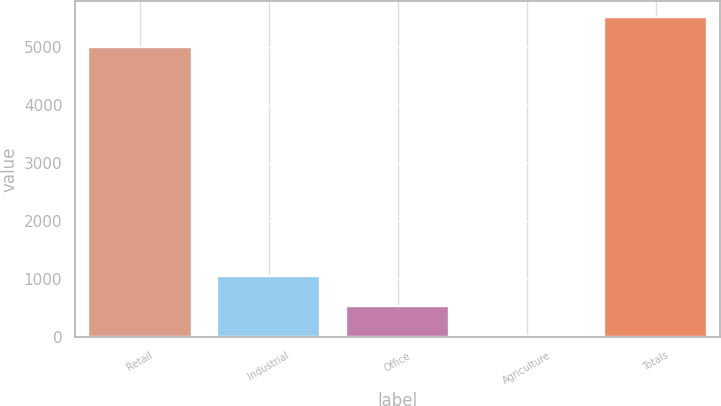Convert chart. <chart><loc_0><loc_0><loc_500><loc_500><bar_chart><fcel>Retail<fcel>Industrial<fcel>Office<fcel>Agriculture<fcel>Totals<nl><fcel>4999<fcel>1046.4<fcel>530.7<fcel>15<fcel>5514.7<nl></chart> 